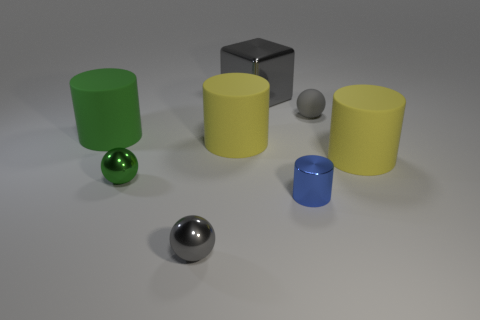Subtract 1 cubes. How many cubes are left? 0 Add 1 red matte things. How many objects exist? 9 Subtract all green balls. How many balls are left? 2 Subtract 0 yellow spheres. How many objects are left? 8 Subtract all blocks. How many objects are left? 7 Subtract all yellow balls. Subtract all green cubes. How many balls are left? 3 Subtract all blue spheres. How many yellow cylinders are left? 2 Subtract all gray cubes. Subtract all tiny green metal balls. How many objects are left? 6 Add 5 small gray metal spheres. How many small gray metal spheres are left? 6 Add 2 big cyan spheres. How many big cyan spheres exist? 2 